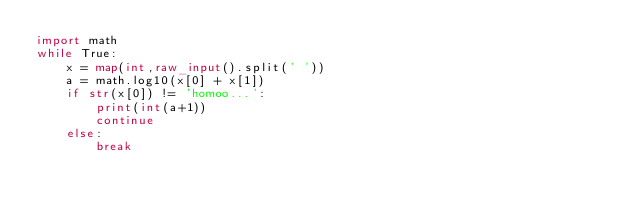<code> <loc_0><loc_0><loc_500><loc_500><_Python_>import math
while True:
	x = map(int,raw_input().split(' '))
	a = math.log10(x[0] + x[1])
	if str(x[0]) != 'homoo...':
		print(int(a+1))
		continue
	else:
		break</code> 